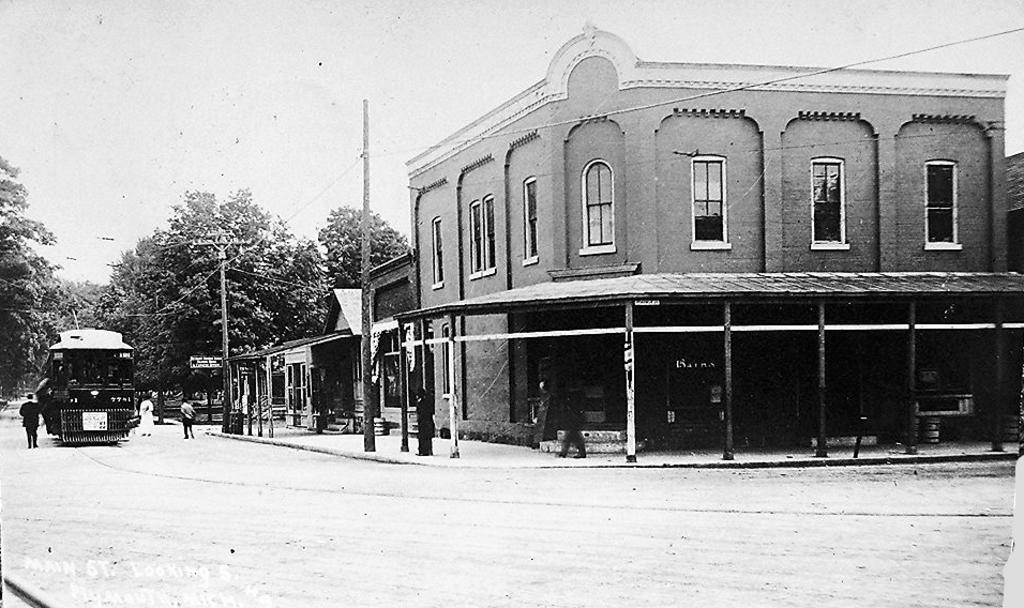What is the color scheme of the image? The image is black and white. What type of surface can be seen in the image? There is ground visible in the image. Are there any living beings in the image? Yes, there are people in the image. What type of man-made structure is present in the image? A vehicle is present in the image. What type of natural elements can be seen in the image? There are trees in the image. What type of vertical structures are visible in the image? Poles are visible in the image. Are there any wires attached to the poles? Yes, wires are present in the image. What type of man-made structures are visible in the image? There is a building and a shed visible in the image. What part of the natural environment is visible in the image? The sky is visible in the image. What type of mitten is being used by the trees in the image? There are no mittens present in the image, and trees do not use mittens. 